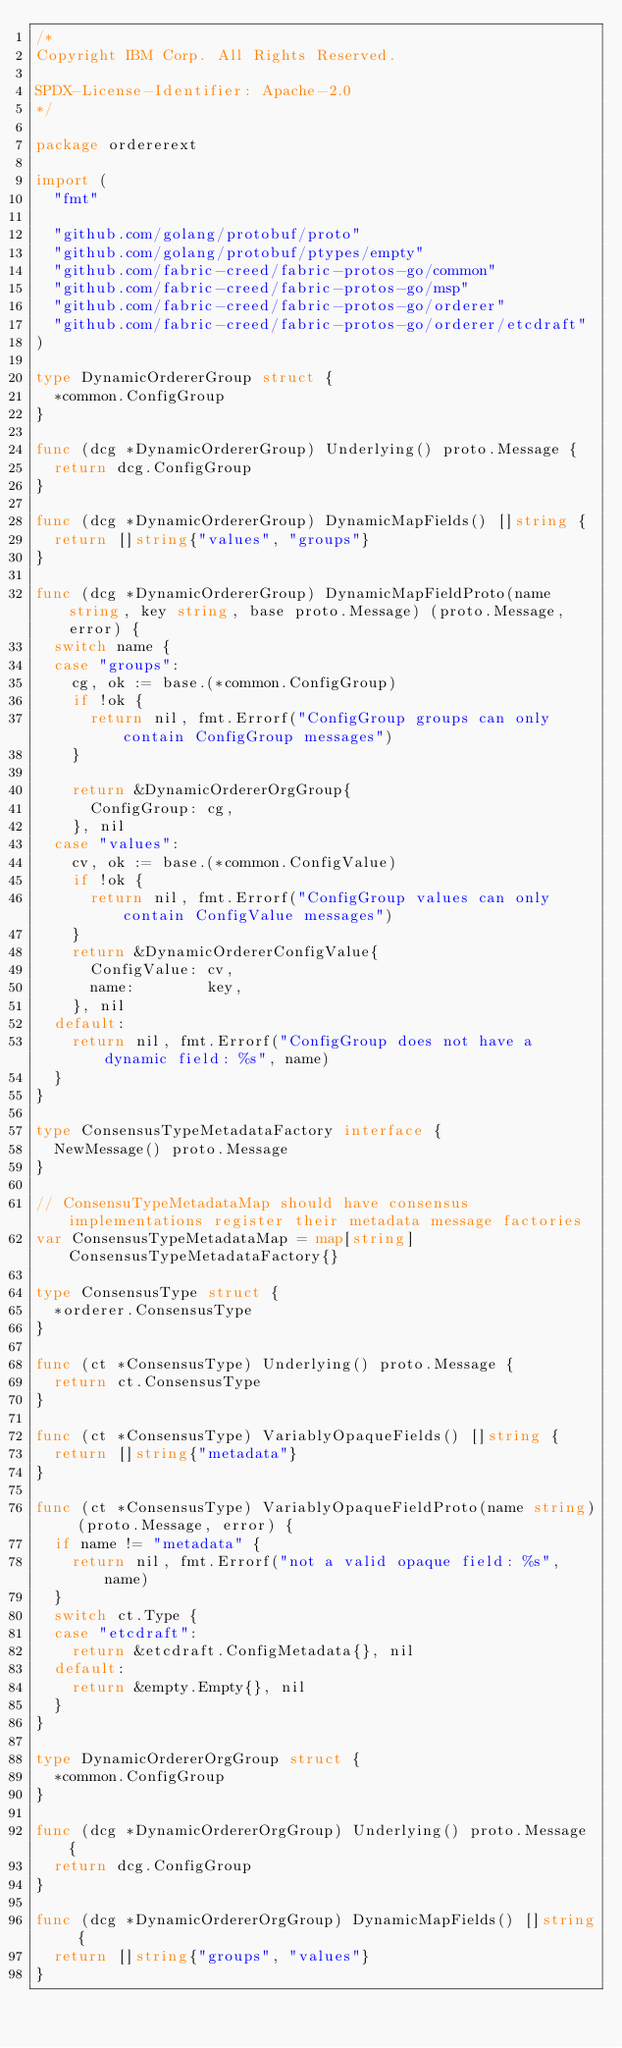<code> <loc_0><loc_0><loc_500><loc_500><_Go_>/*
Copyright IBM Corp. All Rights Reserved.

SPDX-License-Identifier: Apache-2.0
*/

package ordererext

import (
	"fmt"

	"github.com/golang/protobuf/proto"
	"github.com/golang/protobuf/ptypes/empty"
	"github.com/fabric-creed/fabric-protos-go/common"
	"github.com/fabric-creed/fabric-protos-go/msp"
	"github.com/fabric-creed/fabric-protos-go/orderer"
	"github.com/fabric-creed/fabric-protos-go/orderer/etcdraft"
)

type DynamicOrdererGroup struct {
	*common.ConfigGroup
}

func (dcg *DynamicOrdererGroup) Underlying() proto.Message {
	return dcg.ConfigGroup
}

func (dcg *DynamicOrdererGroup) DynamicMapFields() []string {
	return []string{"values", "groups"}
}

func (dcg *DynamicOrdererGroup) DynamicMapFieldProto(name string, key string, base proto.Message) (proto.Message, error) {
	switch name {
	case "groups":
		cg, ok := base.(*common.ConfigGroup)
		if !ok {
			return nil, fmt.Errorf("ConfigGroup groups can only contain ConfigGroup messages")
		}

		return &DynamicOrdererOrgGroup{
			ConfigGroup: cg,
		}, nil
	case "values":
		cv, ok := base.(*common.ConfigValue)
		if !ok {
			return nil, fmt.Errorf("ConfigGroup values can only contain ConfigValue messages")
		}
		return &DynamicOrdererConfigValue{
			ConfigValue: cv,
			name:        key,
		}, nil
	default:
		return nil, fmt.Errorf("ConfigGroup does not have a dynamic field: %s", name)
	}
}

type ConsensusTypeMetadataFactory interface {
	NewMessage() proto.Message
}

// ConsensuTypeMetadataMap should have consensus implementations register their metadata message factories
var ConsensusTypeMetadataMap = map[string]ConsensusTypeMetadataFactory{}

type ConsensusType struct {
	*orderer.ConsensusType
}

func (ct *ConsensusType) Underlying() proto.Message {
	return ct.ConsensusType
}

func (ct *ConsensusType) VariablyOpaqueFields() []string {
	return []string{"metadata"}
}

func (ct *ConsensusType) VariablyOpaqueFieldProto(name string) (proto.Message, error) {
	if name != "metadata" {
		return nil, fmt.Errorf("not a valid opaque field: %s", name)
	}
	switch ct.Type {
	case "etcdraft":
		return &etcdraft.ConfigMetadata{}, nil
	default:
		return &empty.Empty{}, nil
	}
}

type DynamicOrdererOrgGroup struct {
	*common.ConfigGroup
}

func (dcg *DynamicOrdererOrgGroup) Underlying() proto.Message {
	return dcg.ConfigGroup
}

func (dcg *DynamicOrdererOrgGroup) DynamicMapFields() []string {
	return []string{"groups", "values"}
}
</code> 